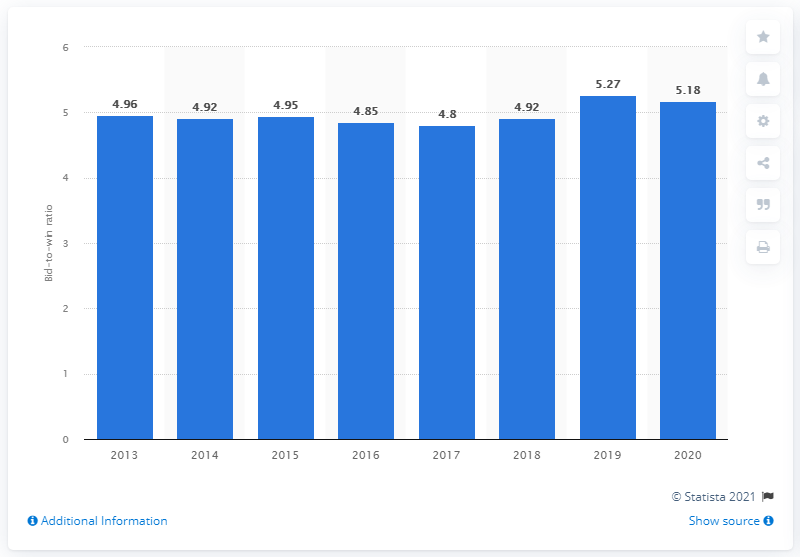Give some essential details in this illustration. The average bid-to-win ratio of professional services organizations in 2020 was 5.18, indicating that the average professional services organization was successful in winning approximately 5.18 out of every 10 bids they submitted in 2020. 